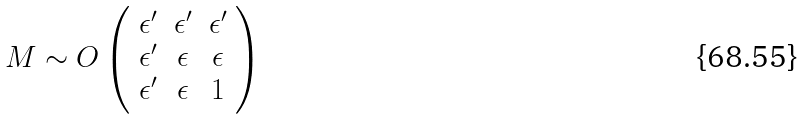<formula> <loc_0><loc_0><loc_500><loc_500>M \sim O \left ( \begin{array} { c c c } \epsilon ^ { \prime } & \epsilon ^ { \prime } & \epsilon ^ { \prime } \\ \epsilon ^ { \prime } & \epsilon & \epsilon \\ \epsilon ^ { \prime } & \epsilon & 1 \end{array} \right )</formula> 